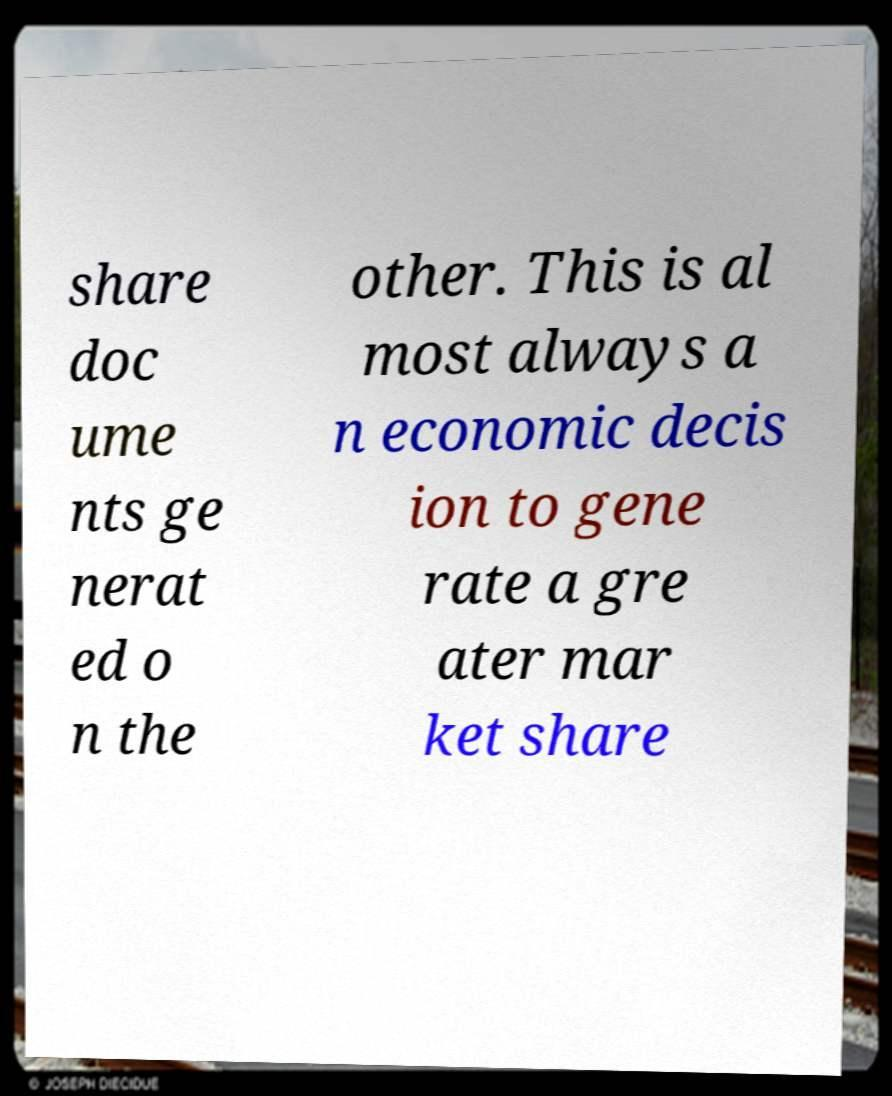Can you accurately transcribe the text from the provided image for me? share doc ume nts ge nerat ed o n the other. This is al most always a n economic decis ion to gene rate a gre ater mar ket share 